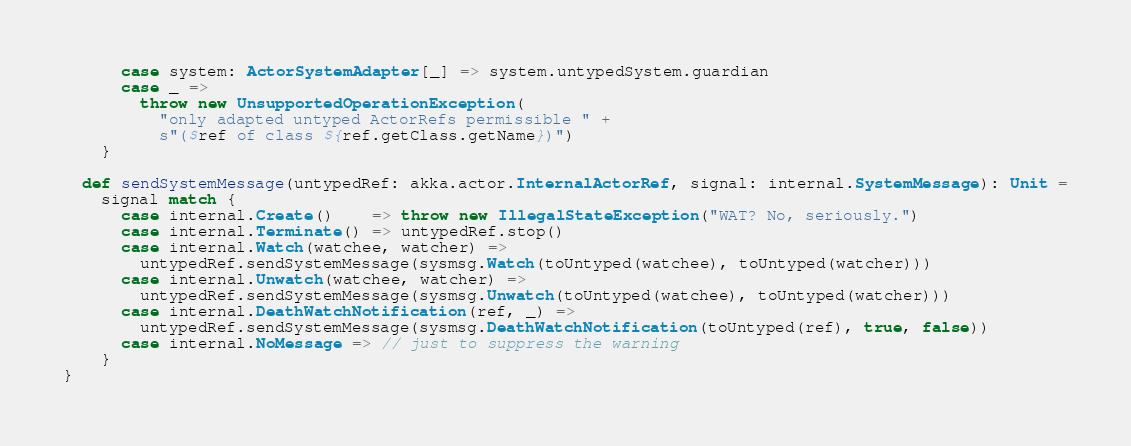<code> <loc_0><loc_0><loc_500><loc_500><_Scala_>      case system: ActorSystemAdapter[_] => system.untypedSystem.guardian
      case _ =>
        throw new UnsupportedOperationException(
          "only adapted untyped ActorRefs permissible " +
          s"($ref of class ${ref.getClass.getName})")
    }

  def sendSystemMessage(untypedRef: akka.actor.InternalActorRef, signal: internal.SystemMessage): Unit =
    signal match {
      case internal.Create()    => throw new IllegalStateException("WAT? No, seriously.")
      case internal.Terminate() => untypedRef.stop()
      case internal.Watch(watchee, watcher) =>
        untypedRef.sendSystemMessage(sysmsg.Watch(toUntyped(watchee), toUntyped(watcher)))
      case internal.Unwatch(watchee, watcher) =>
        untypedRef.sendSystemMessage(sysmsg.Unwatch(toUntyped(watchee), toUntyped(watcher)))
      case internal.DeathWatchNotification(ref, _) =>
        untypedRef.sendSystemMessage(sysmsg.DeathWatchNotification(toUntyped(ref), true, false))
      case internal.NoMessage => // just to suppress the warning
    }
}
</code> 